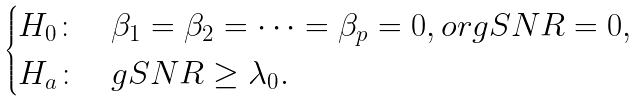Convert formula to latex. <formula><loc_0><loc_0><loc_500><loc_500>\begin{cases} H _ { 0 } \colon & \beta _ { 1 } = \beta _ { 2 } = \dots = \beta _ { p } = 0 , o r g S N R = 0 , \\ H _ { a } \colon & g S N R \geq \lambda _ { 0 } . \end{cases}</formula> 